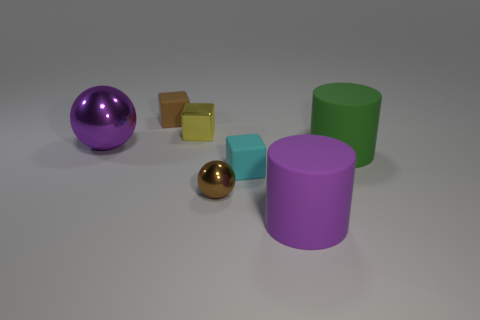Add 1 big matte things. How many objects exist? 8 Subtract all balls. How many objects are left? 5 Subtract all cylinders. Subtract all brown things. How many objects are left? 3 Add 5 tiny cyan things. How many tiny cyan things are left? 6 Add 5 small brown cubes. How many small brown cubes exist? 6 Subtract 0 red balls. How many objects are left? 7 